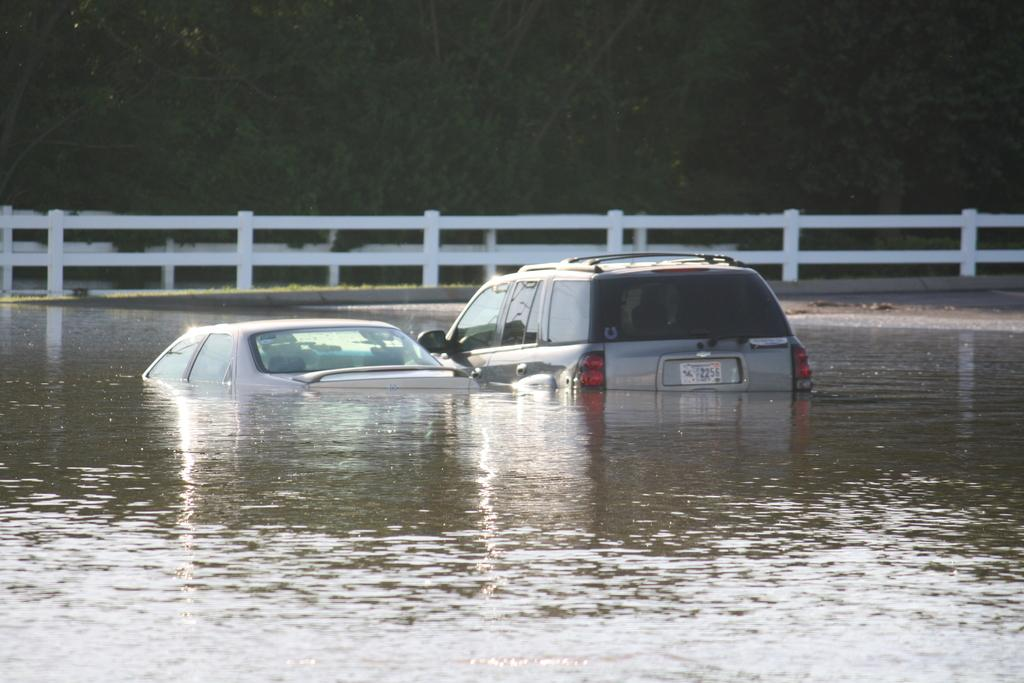What is the main subject of the image? The main subject of the image is two cars in the water. What can be seen in the background of the image? In the background of the image, there is a fence and many trees. What type of story is being told by the judge in the image? There is no judge present in the image, and therefore no story being told by a judge. 